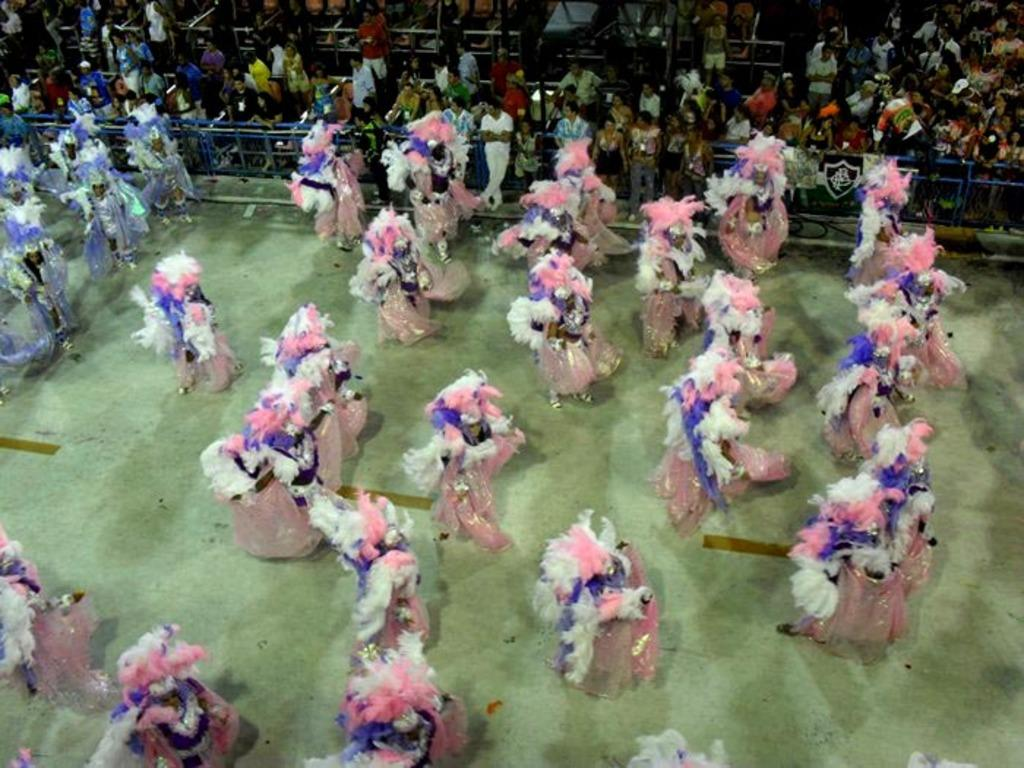What are the people in the image wearing? The people in the image are wearing costumes. What are the people in the image doing? The people are standing. What can be seen in the background of the image? There are many people standing in the background of the image. What is the fencing used for in the image? The fencing is visible from left to right in the image, possibly to separate or guide people. What type of sound can be heard coming from the plane in the image? There is no plane present in the image, so no sound can be heard from a plane. 